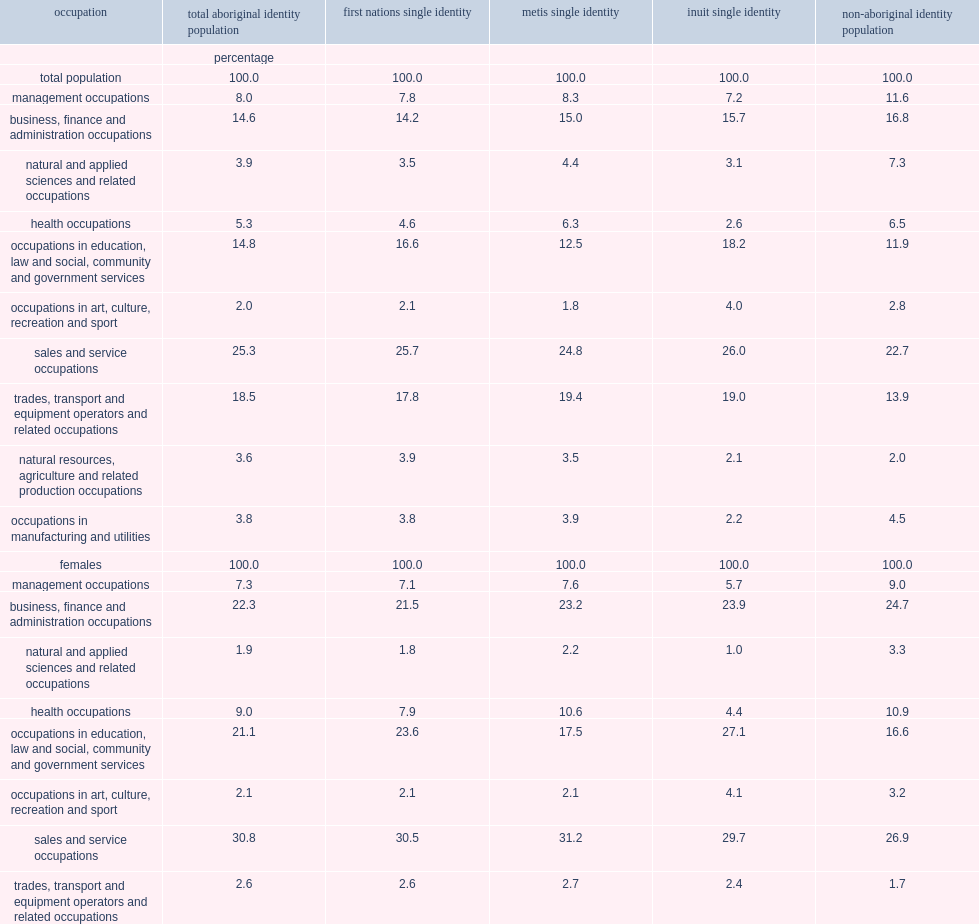How many percent were aboriginal women aged 15 years and over most likely to be employed in sales and service occupations? 30.8. How many percent were aboriginal women aged 15 years and over more likely to be employed in business, finance, and administrative occupations? 22.3. How many percent were aboriginal women aged 15 years and over more likely to be employed in occupations in education, law and social, community and government services? 21.1. How many percent were aboriginal men were more likely to be employed in trades, transport and equipment operators and related occupations? 34.8. How many percent were aboriginal men more likely to be employed in sales and service occupations? 19.8. In 2011, how many percent of aboriginal women reported having managerial positions? 7.3. In 2011, how many percent of non-aboriginal women reported having managerial positions? 9.0. What was the proportion of first nations reporting management occupations? 7.1. What was the proportion of metis women reporting management occupations? 7.6. What was the proportion of inuit women reporting management occupations? 5.7. 